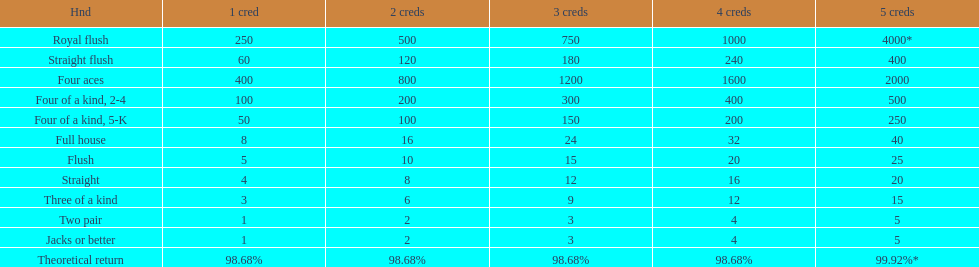Is a 2 credit full house the same as a 5 credit three of a kind? No. 